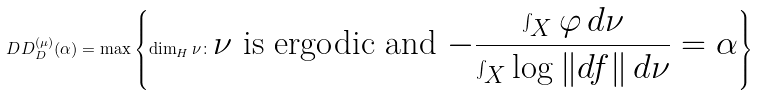<formula> <loc_0><loc_0><loc_500><loc_500>\ D D _ { D } ^ { ( \mu ) } ( \alpha ) = \max \left \{ \dim _ { H } \nu \colon \text {$\nu$ is ergodic and $-\frac{\int_{X}\varphi \,d\nu}{\int_{X}\log\| df\|\,d\nu}=\alpha$} \right \}</formula> 